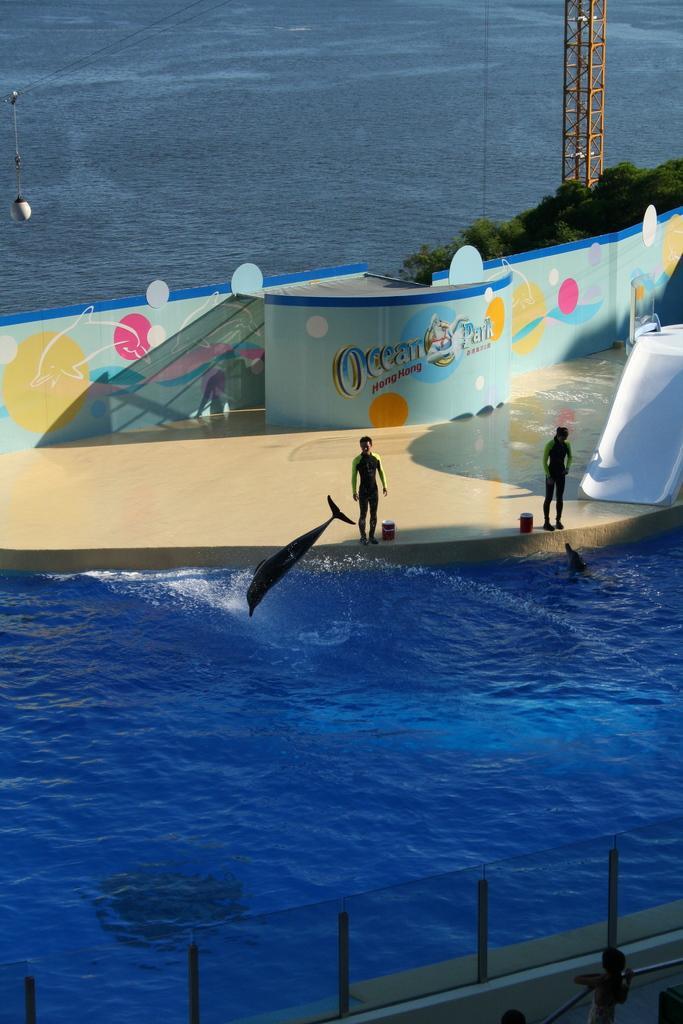Please provide a concise description of this image. I can see in this image water and a tower. I can also see few people on the floor. In the water there are dolphins, on the right side I can see trees. 